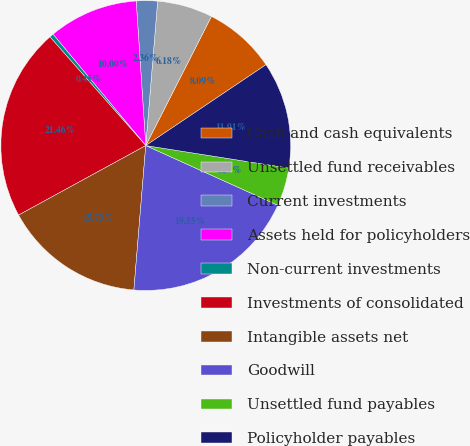<chart> <loc_0><loc_0><loc_500><loc_500><pie_chart><fcel>Cash and cash equivalents<fcel>Unsettled fund receivables<fcel>Current investments<fcel>Assets held for policyholders<fcel>Non-current investments<fcel>Investments of consolidated<fcel>Intangible assets net<fcel>Goodwill<fcel>Unsettled fund payables<fcel>Policyholder payables<nl><fcel>8.09%<fcel>6.18%<fcel>2.36%<fcel>10.0%<fcel>0.45%<fcel>21.46%<fcel>15.73%<fcel>19.55%<fcel>4.27%<fcel>11.91%<nl></chart> 